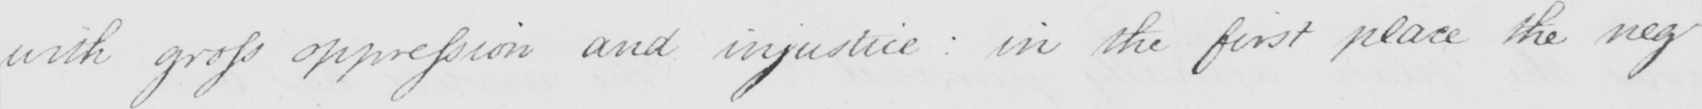What text is written in this handwritten line? with gross oppression and injustice :  in the first place the neg- 